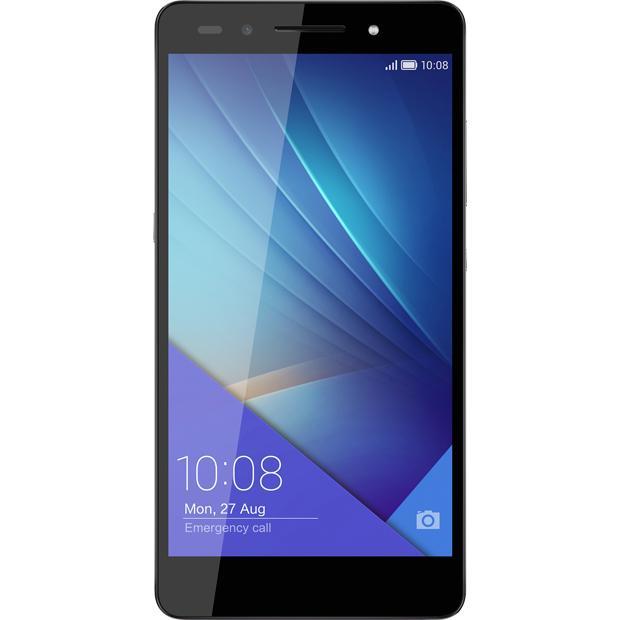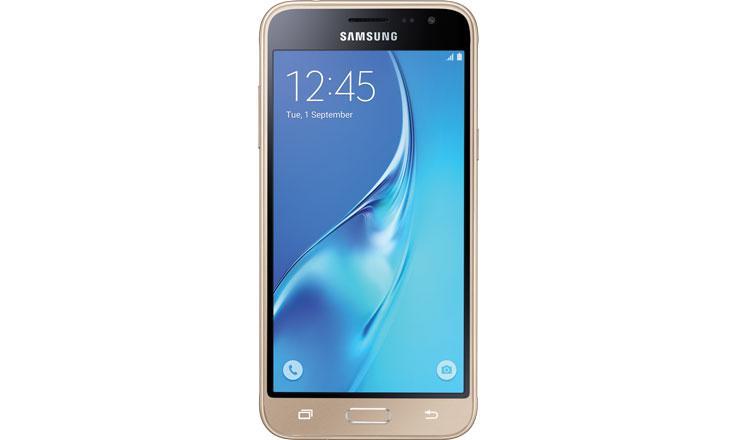The first image is the image on the left, the second image is the image on the right. Considering the images on both sides, is "There are no more than 2 phones." valid? Answer yes or no. Yes. The first image is the image on the left, the second image is the image on the right. Considering the images on both sides, is "there are two phones in the image pair" valid? Answer yes or no. Yes. 